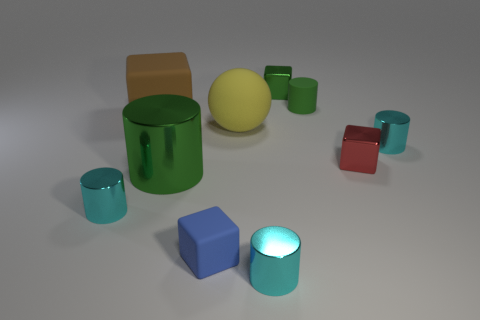There is a green object that is to the left of the small metallic thing that is behind the tiny metallic cylinder behind the green metallic cylinder; what is its shape?
Keep it short and to the point. Cylinder. There is another large object that is the same shape as the green rubber thing; what is it made of?
Keep it short and to the point. Metal. What number of small blue objects are there?
Provide a short and direct response. 1. The tiny rubber thing behind the tiny red block has what shape?
Offer a terse response. Cylinder. What is the color of the rubber object in front of the tiny cyan metal thing that is left of the rubber thing in front of the yellow thing?
Give a very brief answer. Blue. There is a large green thing that is made of the same material as the small red thing; what is its shape?
Offer a terse response. Cylinder. Are there fewer blue matte blocks than small shiny cubes?
Your answer should be very brief. Yes. Is the material of the tiny red thing the same as the yellow ball?
Your answer should be compact. No. What number of other objects are there of the same color as the rubber ball?
Give a very brief answer. 0. Are there more yellow matte cylinders than red things?
Keep it short and to the point. No. 